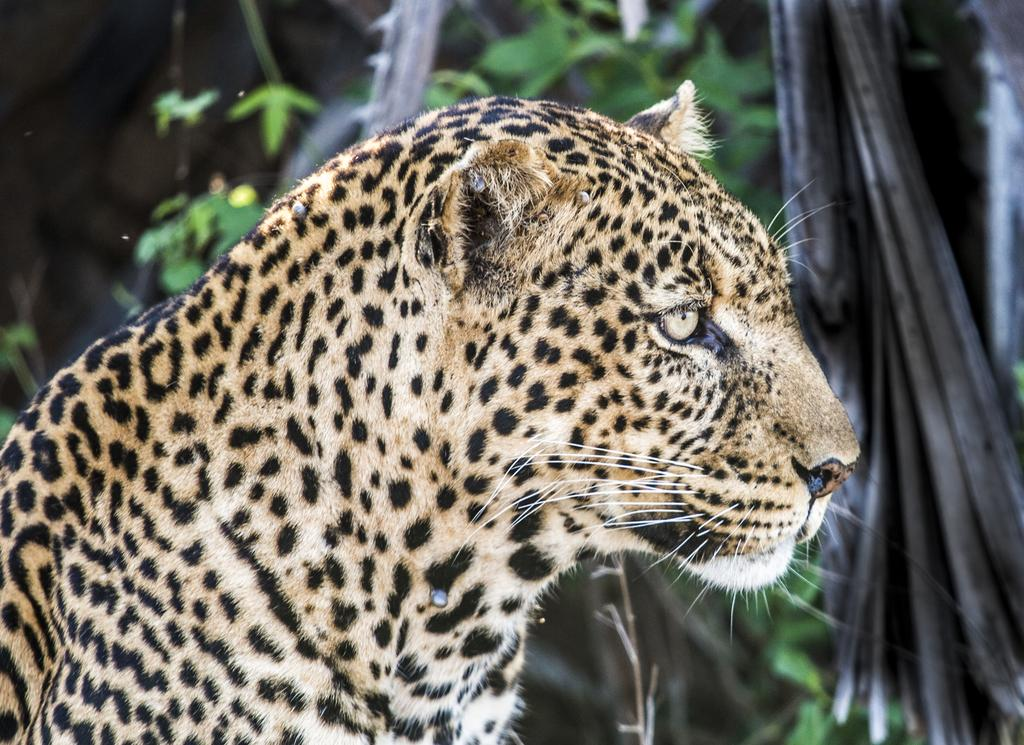What type of living organism is present in the image? There is an animal in the image. What can be seen in the background of the image? There are leaves visible in the background of the image. What type of sign is the animal holding in the image? There is no sign present in the image, and the animal is not holding anything. Can you tell me how many grandmothers are visible in the image? There are no grandmothers present in the image. 